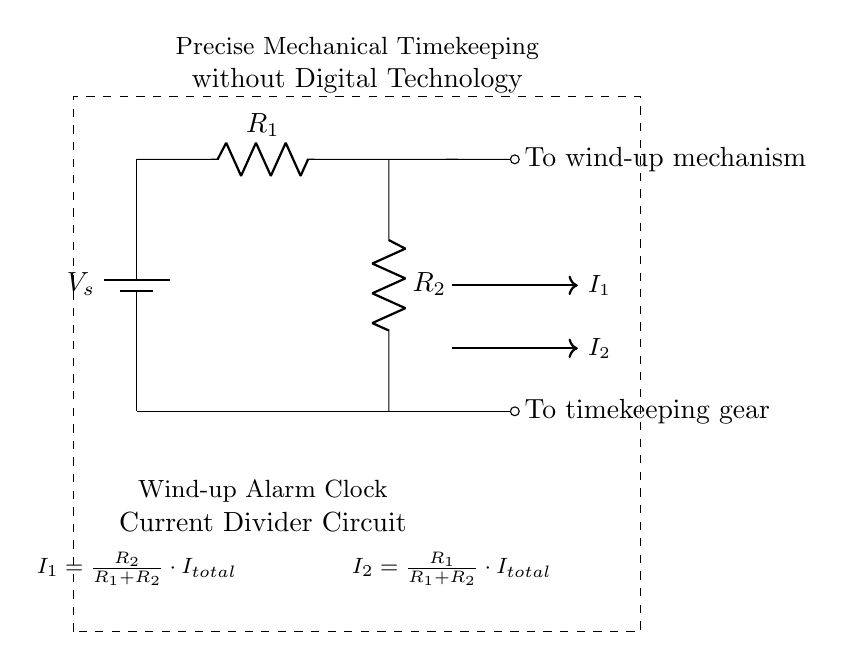What is the total current flowing in the circuit? The total current, denoted as I total, is the sum of the currents I1 and I2 flowing through resistors R1 and R2. In a current divider, total current entering the divided path equals the sum of the currents leaving the path.
Answer: I total What are the resistances in the circuit? The circuit contains two resistors labeled R1 and R2. These resistors divide the total current based on their resistance values. They are critical components for the current divider function.
Answer: R1, R2 What is the purpose of R1 in this circuit? Resistor R1 is part of the current divider, which helps distribute the total current based on its resistance compared to R2. It controls the amount of current that flows through the winding mechanism and affects the timing of the clock.
Answer: Current division How does current I1 compare to current I2 in this circuit? Current I1 flows through resistor R2 while I2 flows through R1. Based on the current divider rule, the current through each resistor is inversely proportional to its resistance. Therefore, the relationship is determined by the ratio of the resistances, which can be represented mathematically as I1/I2 = R1/R2.
Answer: I1 is related to R2 What does the dashed rectangle represent in the circuit diagram? The dashed rectangle signifies the boundaries of the wind-up alarm clock current divider circuit. It visually separates the circuit from the rest of the diagram, indicating it is a distinct unit designed for precise timekeeping.
Answer: Circuit boundaries What happens to the total current if R1 is increased? If R1 is increased while keeping R2 constant, the total current flowing in the circuit may decrease since the higher resistance will reduce the overall current due to Ohm's law; this means that I2 will increase, while I1 will decrease.
Answer: Total current decreases 